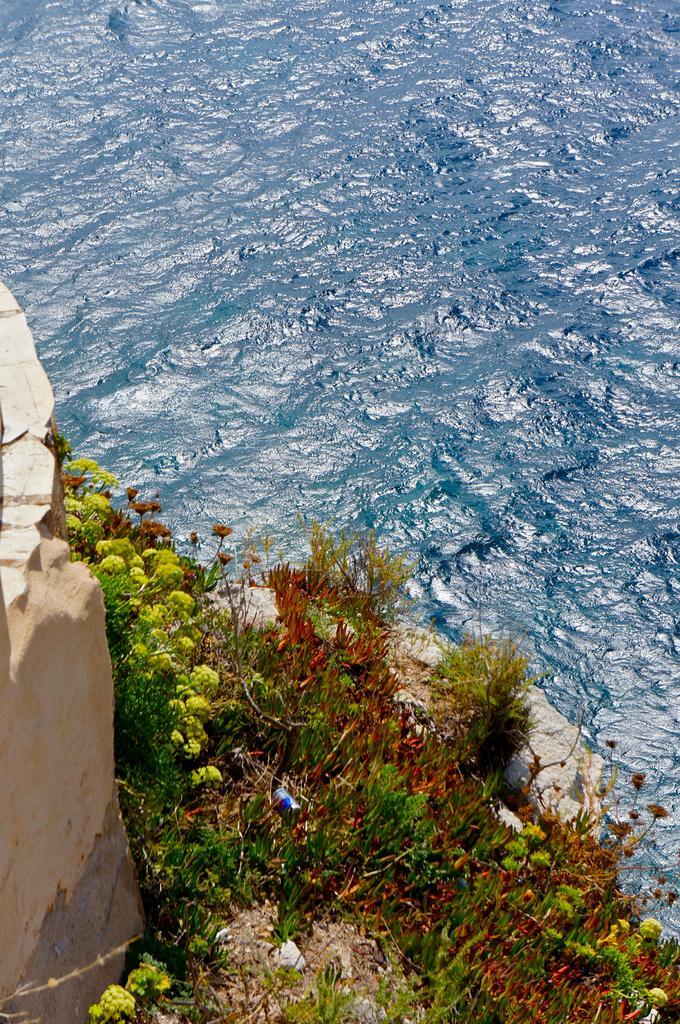What is the main element in the picture? There is water in the picture. What is the color of the water? The water is blue in color. Are there any plants visible in the picture? Yes, there are plants near the water. What else can be seen in the picture? There is a wall in the picture. Can you see any volcanoes erupting in the picture? There are no volcanoes present in the image, and therefore no eruptions can be observed. What type of silk is being used to make the plants in the picture? There is no silk present in the image; the plants are real. 